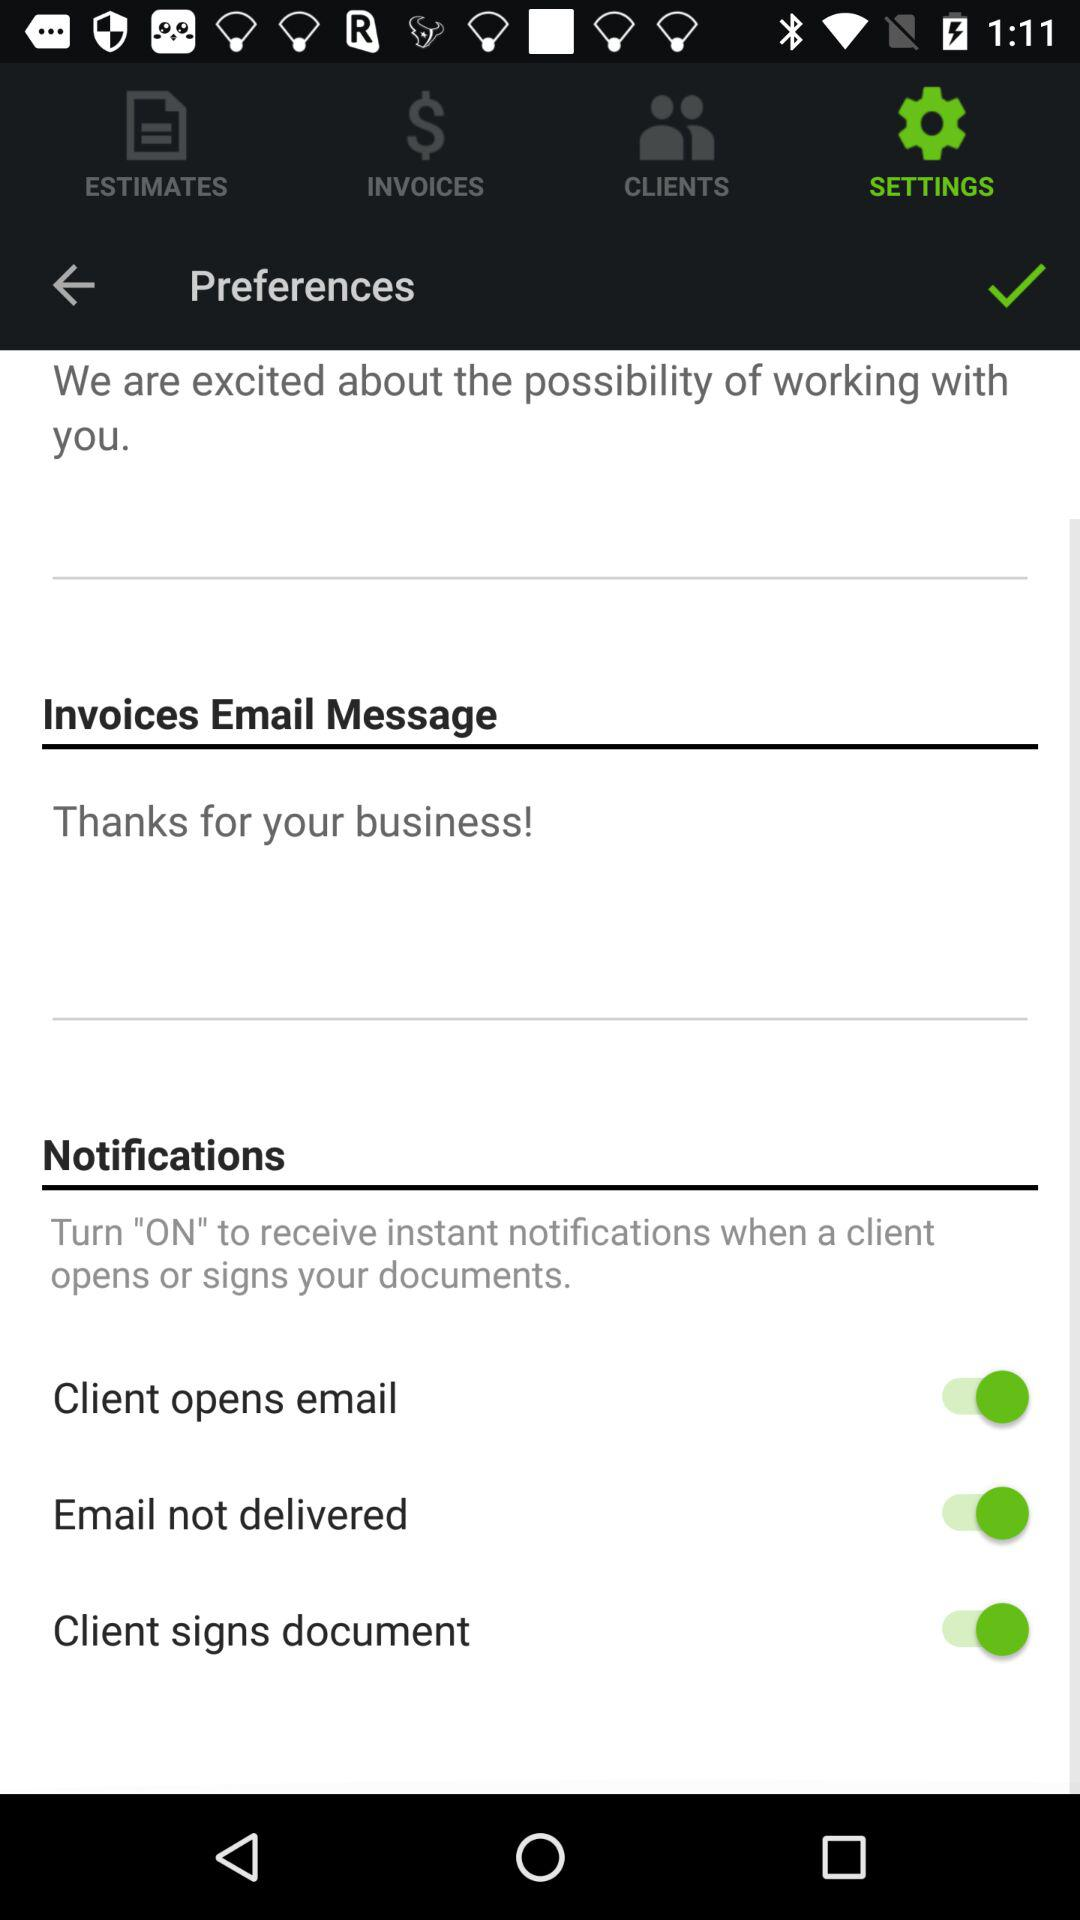What is the status of "Email not delivered"? The status is "on". 